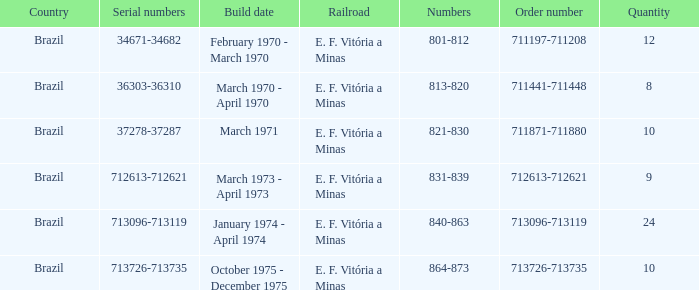Could you parse the entire table as a dict? {'header': ['Country', 'Serial numbers', 'Build date', 'Railroad', 'Numbers', 'Order number', 'Quantity'], 'rows': [['Brazil', '34671-34682', 'February 1970 - March 1970', 'E. F. Vitória a Minas', '801-812', '711197-711208', '12'], ['Brazil', '36303-36310', 'March 1970 - April 1970', 'E. F. Vitória a Minas', '813-820', '711441-711448', '8'], ['Brazil', '37278-37287', 'March 1971', 'E. F. Vitória a Minas', '821-830', '711871-711880', '10'], ['Brazil', '712613-712621', 'March 1973 - April 1973', 'E. F. Vitória a Minas', '831-839', '712613-712621', '9'], ['Brazil', '713096-713119', 'January 1974 - April 1974', 'E. F. Vitória a Minas', '840-863', '713096-713119', '24'], ['Brazil', '713726-713735', 'October 1975 - December 1975', 'E. F. Vitória a Minas', '864-873', '713726-713735', '10']]} What country has the order number 711871-711880? Brazil. 